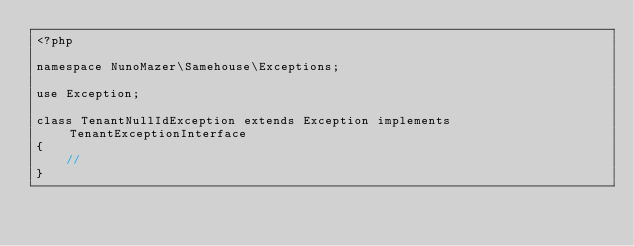Convert code to text. <code><loc_0><loc_0><loc_500><loc_500><_PHP_><?php

namespace NunoMazer\Samehouse\Exceptions;

use Exception;

class TenantNullIdException extends Exception implements TenantExceptionInterface
{
    //
}
</code> 